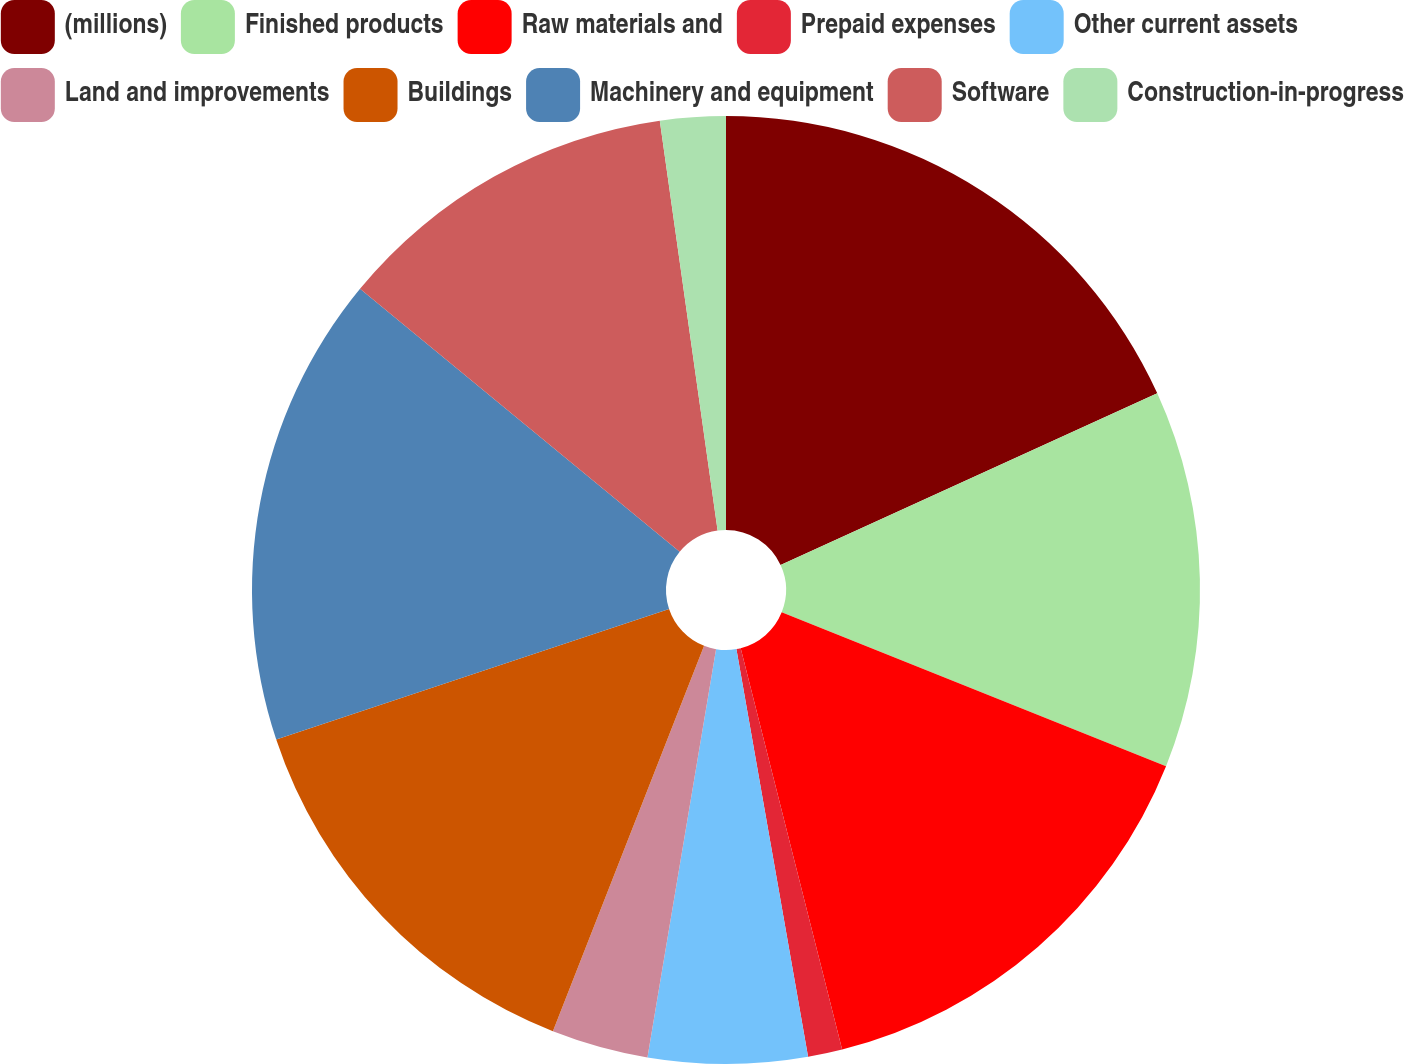Convert chart to OTSL. <chart><loc_0><loc_0><loc_500><loc_500><pie_chart><fcel>(millions)<fcel>Finished products<fcel>Raw materials and<fcel>Prepaid expenses<fcel>Other current assets<fcel>Land and improvements<fcel>Buildings<fcel>Machinery and equipment<fcel>Software<fcel>Construction-in-progress<nl><fcel>18.19%<fcel>12.87%<fcel>15.0%<fcel>1.17%<fcel>5.42%<fcel>3.3%<fcel>13.94%<fcel>16.07%<fcel>11.81%<fcel>2.23%<nl></chart> 